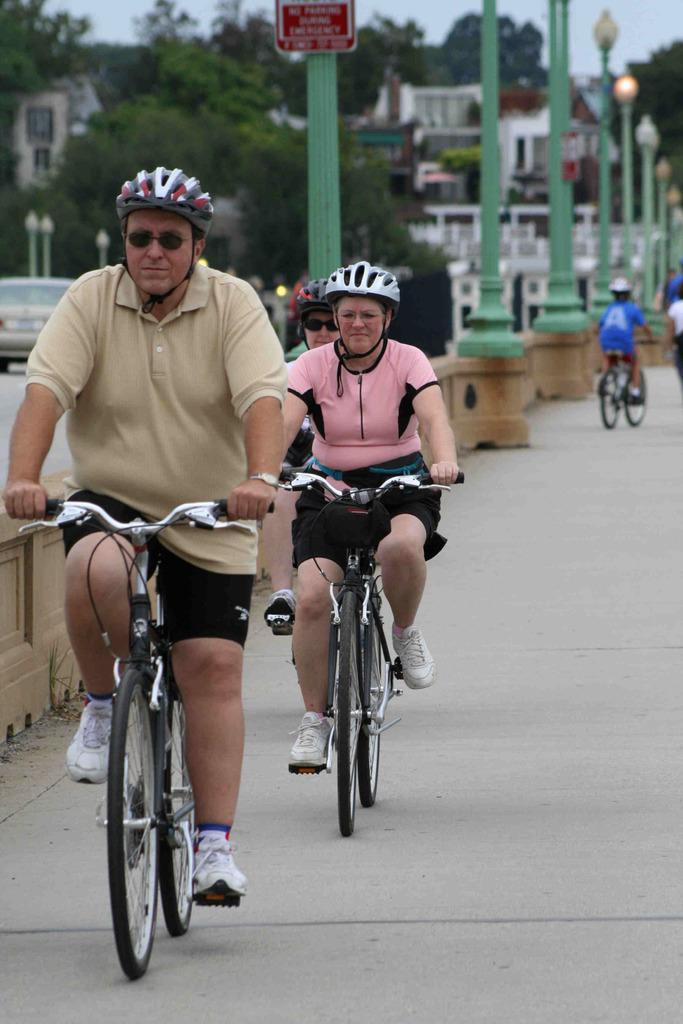Please provide a concise description of this image. This is an outside view. In this image I can see few people are riding their bicycles on the road. Everyone are wearing helmets on their heads. In the background there are some buildings and trees and also I can see few pillars on the middle of the road. 